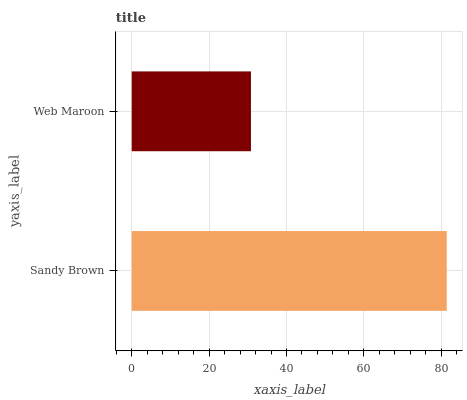Is Web Maroon the minimum?
Answer yes or no. Yes. Is Sandy Brown the maximum?
Answer yes or no. Yes. Is Web Maroon the maximum?
Answer yes or no. No. Is Sandy Brown greater than Web Maroon?
Answer yes or no. Yes. Is Web Maroon less than Sandy Brown?
Answer yes or no. Yes. Is Web Maroon greater than Sandy Brown?
Answer yes or no. No. Is Sandy Brown less than Web Maroon?
Answer yes or no. No. Is Sandy Brown the high median?
Answer yes or no. Yes. Is Web Maroon the low median?
Answer yes or no. Yes. Is Web Maroon the high median?
Answer yes or no. No. Is Sandy Brown the low median?
Answer yes or no. No. 